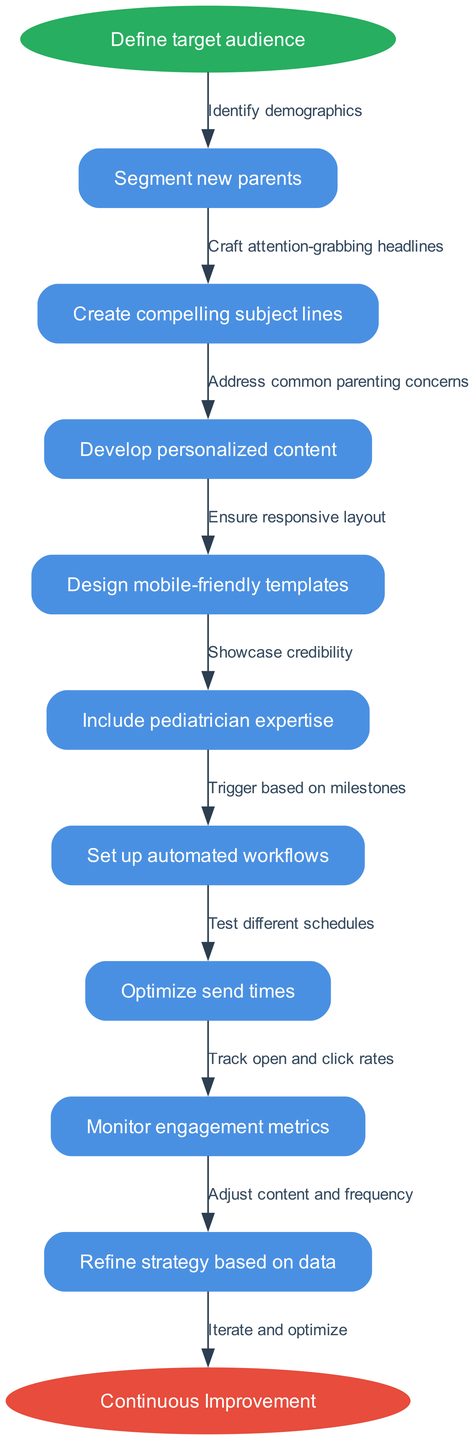What is the starting point of the diagram? The starting point of the diagram is indicated by the 'start' node. According to the diagram, the starting node is labeled "Define target audience."
Answer: Define target audience How many nodes are present in the diagram? The diagram lists all the nodes contained within it, which are the steps in the email marketing strategy. By counting these nodes, we determine there are 9 nodes in total.
Answer: 9 What is the relationship between "Define target audience" and "Segment new parents"? In the diagram, the first node "Define target audience" points to the next node "Segment new parents," indicating that segmenting new parents is the next step in the marketing strategy after defining the target audience.
Answer: Segment new parents Which node includes pediatrician expertise? Among the various nodes in the diagram, "Include pediatrician expertise" is specifically mentioned as a distinct step in the process. This identifies that this step focuses on showcasing the pediatrician's credibility.
Answer: Include pediatrician expertise What is the final node in the flow chart? The flowchart concludes with a final node labeled "Continuous Improvement." It represents the ultimate aim after executing the strategy, emphasizing the importance of ongoing refinement and optimization.
Answer: Continuous Improvement What is the edge that connects "Develop personalized content" to its preceding node? Looking at the diagram, the edge connecting "Develop personalized content" specifies the action or reasoning that precedes this step. The edge indicates it is built on addressing common parenting concerns.
Answer: Address common parenting concerns How many edges connect the nodes in the diagram? Each transition or relationship between nodes in the flowchart is represented by an edge. Since there are 9 nodes, there will be 8 edges connecting these nodes sequentially.
Answer: 8 What does "Optimize send times" relate to in the diagram? The node "Optimize send times" is connected by an edge labeled "Test different schedules," indicating a strategy or method that informs the decision on optimizing when emails should be sent for maximum engagement.
Answer: Test different schedules What step comes after setting up automated workflows? The flowchart clearly dictates the sequential nature of actions. Following "Set up automated workflows," the next step is "Optimize send times," suggesting that optimizing send times is an important part of the automation process.
Answer: Optimize send times 